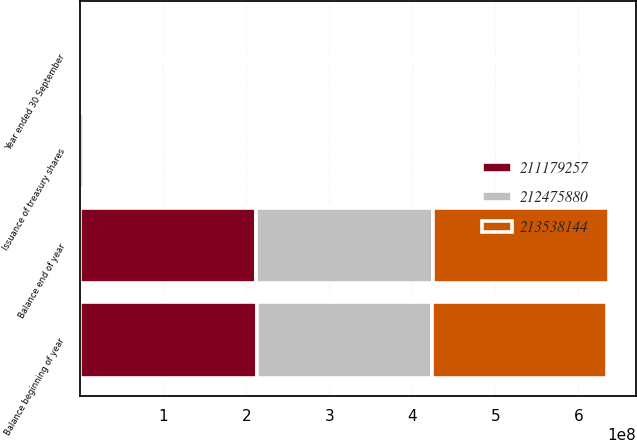<chart> <loc_0><loc_0><loc_500><loc_500><stacked_bar_chart><ecel><fcel>Year ended 30 September<fcel>Balance beginning of year<fcel>Issuance of treasury shares<fcel>Balance end of year<nl><fcel>2.12476e+08<fcel>2014<fcel>2.11179e+08<fcel>2.35889e+06<fcel>2.13538e+08<nl><fcel>2.11179e+08<fcel>2013<fcel>2.12476e+08<fcel>4.42439e+06<fcel>2.11179e+08<nl><fcel>2.13538e+08<fcel>2012<fcel>2.10185e+08<fcel>2.88554e+06<fcel>2.12476e+08<nl></chart> 